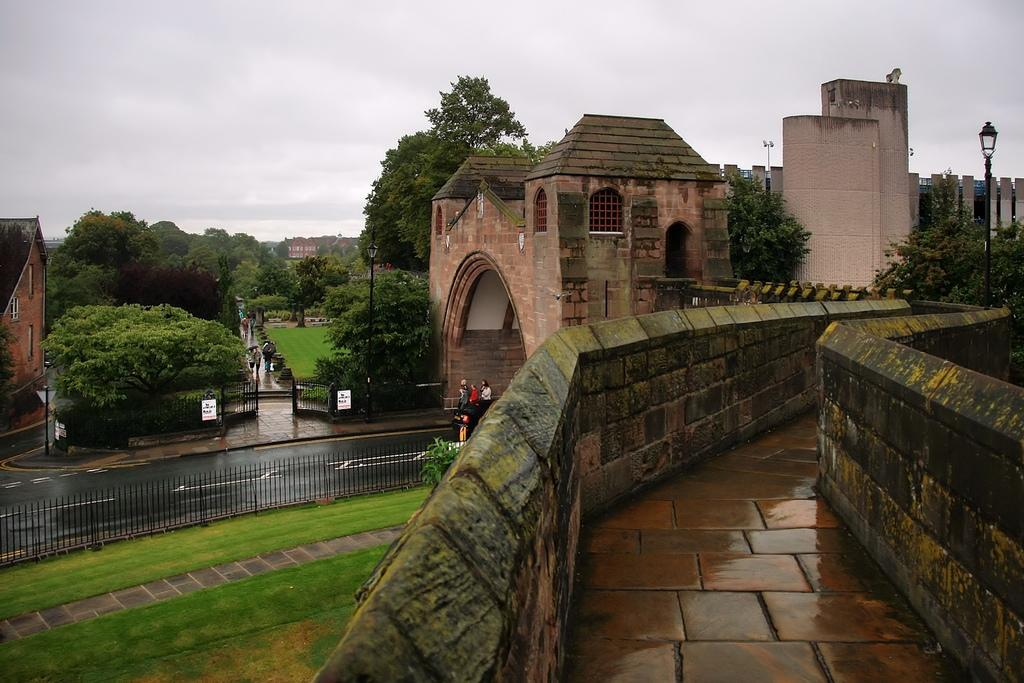What type of structures can be seen in the image? There are buildings in the image. What features do the buildings have? The buildings have windows. What natural elements are present in the image? There are trees in the image. What type of barrier is visible in the image? There is fencing in the image. Who or what is present in the image? There are people in the image. What type of lighting is present in the image? There are light poles in the image. What is attached to the fencing in the image? There are boards attached to the fencing. What part of the natural environment is visible in the image? The sky is visible in the image. Can you tell me where the star is located in the image? There is no star present in the image. What type of throne can be seen in the image? There is no throne present in the image. 